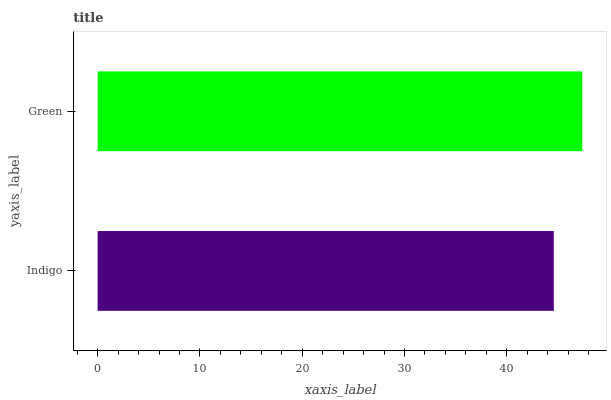Is Indigo the minimum?
Answer yes or no. Yes. Is Green the maximum?
Answer yes or no. Yes. Is Green the minimum?
Answer yes or no. No. Is Green greater than Indigo?
Answer yes or no. Yes. Is Indigo less than Green?
Answer yes or no. Yes. Is Indigo greater than Green?
Answer yes or no. No. Is Green less than Indigo?
Answer yes or no. No. Is Green the high median?
Answer yes or no. Yes. Is Indigo the low median?
Answer yes or no. Yes. Is Indigo the high median?
Answer yes or no. No. Is Green the low median?
Answer yes or no. No. 